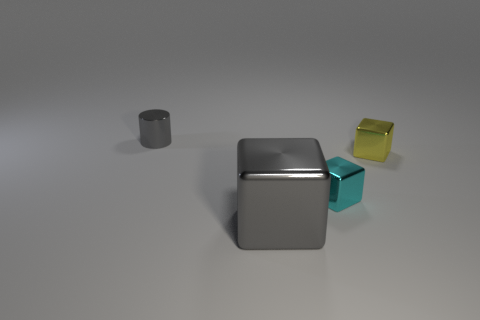How might the objects be used in real life, given their shapes and materials? Based on their shapes and perceived materials, the metallic cube could serve as a decorative item or housing for a piece of technology, like a computer case or a minimalist artistic structure. The frosted glass-like cube might be part of a larger architectural model, perhaps a representation of glass blocks used in construction. The small yellow cube could be a simple paperweight or a toy block. 